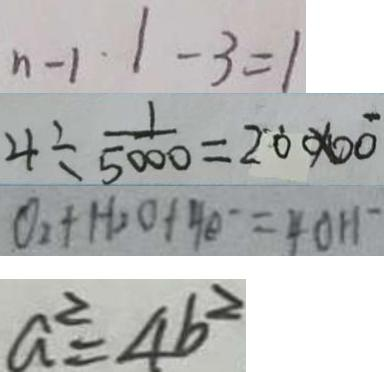<formula> <loc_0><loc_0><loc_500><loc_500>n - 1 \cdot 1 - 3 = 1 
 4 \div \frac { 1 } { 5 0 0 0 } = 2 0 0 0 0 
 O _ { 2 } + H _ { 2 } O + 4 e ^ { - } = 4 0 H ^ { - } 
 a ^ { 2 } = 4 b ^ { 2 }</formula> 